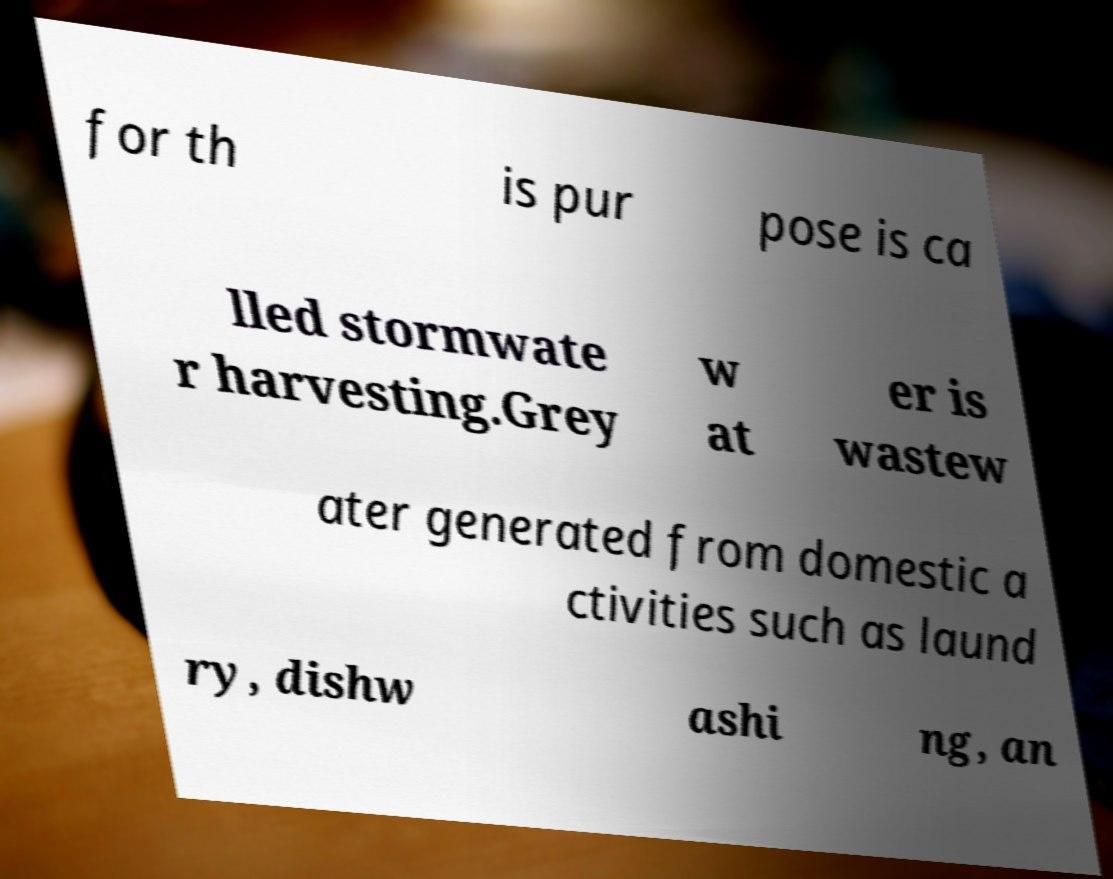Could you extract and type out the text from this image? for th is pur pose is ca lled stormwate r harvesting.Grey w at er is wastew ater generated from domestic a ctivities such as laund ry, dishw ashi ng, an 